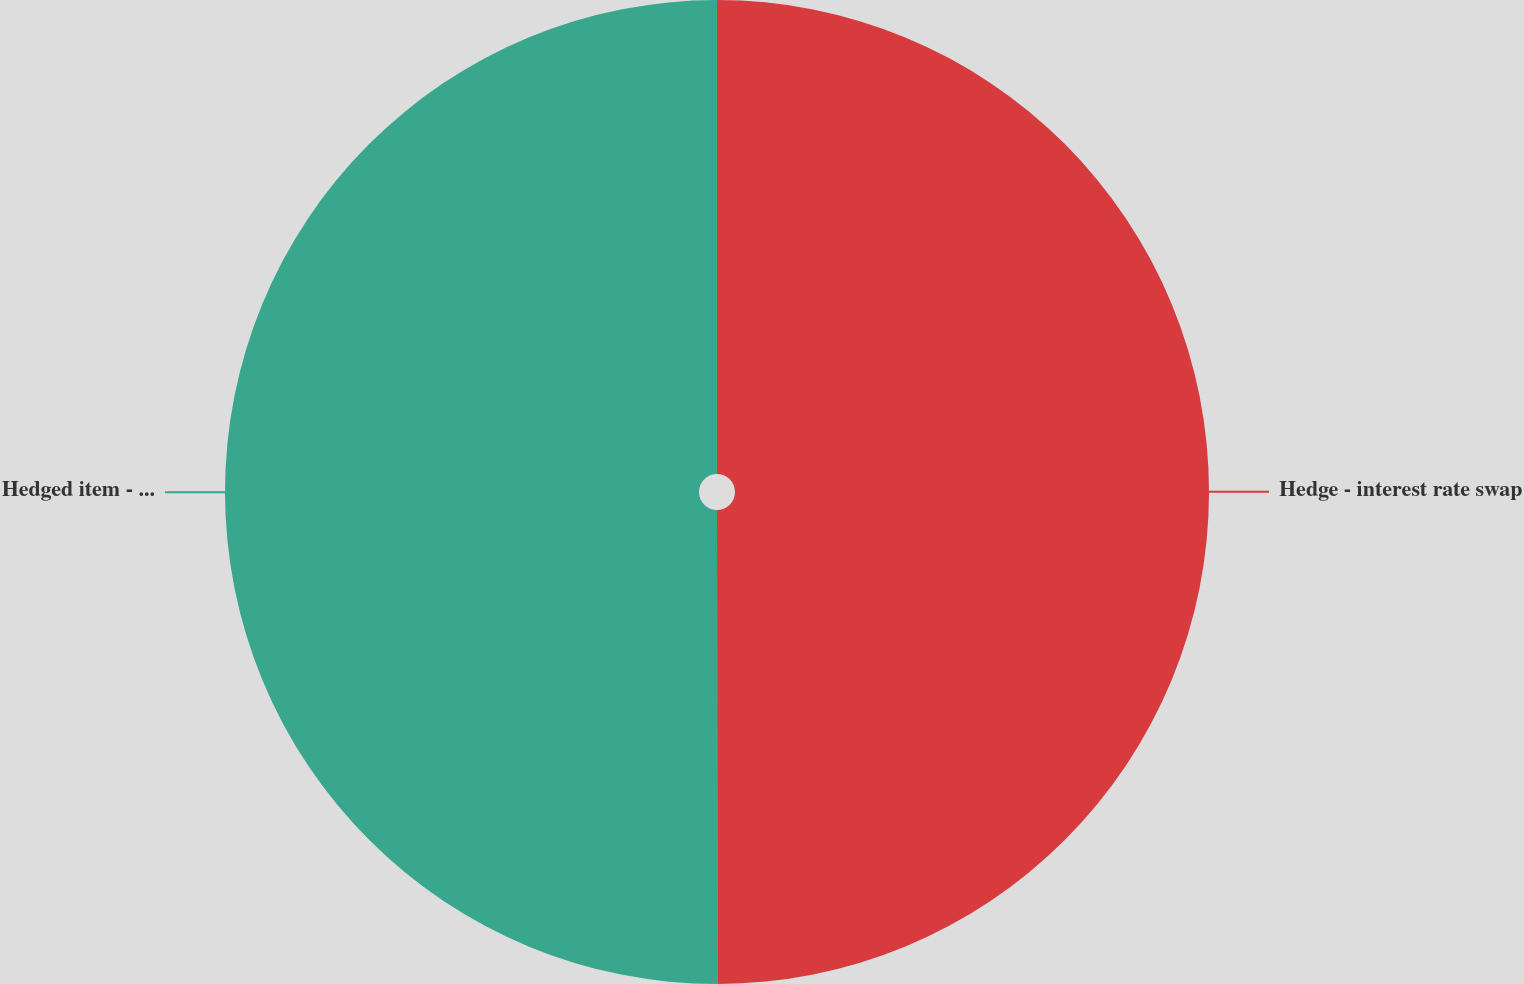Convert chart to OTSL. <chart><loc_0><loc_0><loc_500><loc_500><pie_chart><fcel>Hedge - interest rate swap<fcel>Hedged item - long-term debt<nl><fcel>49.99%<fcel>50.01%<nl></chart> 